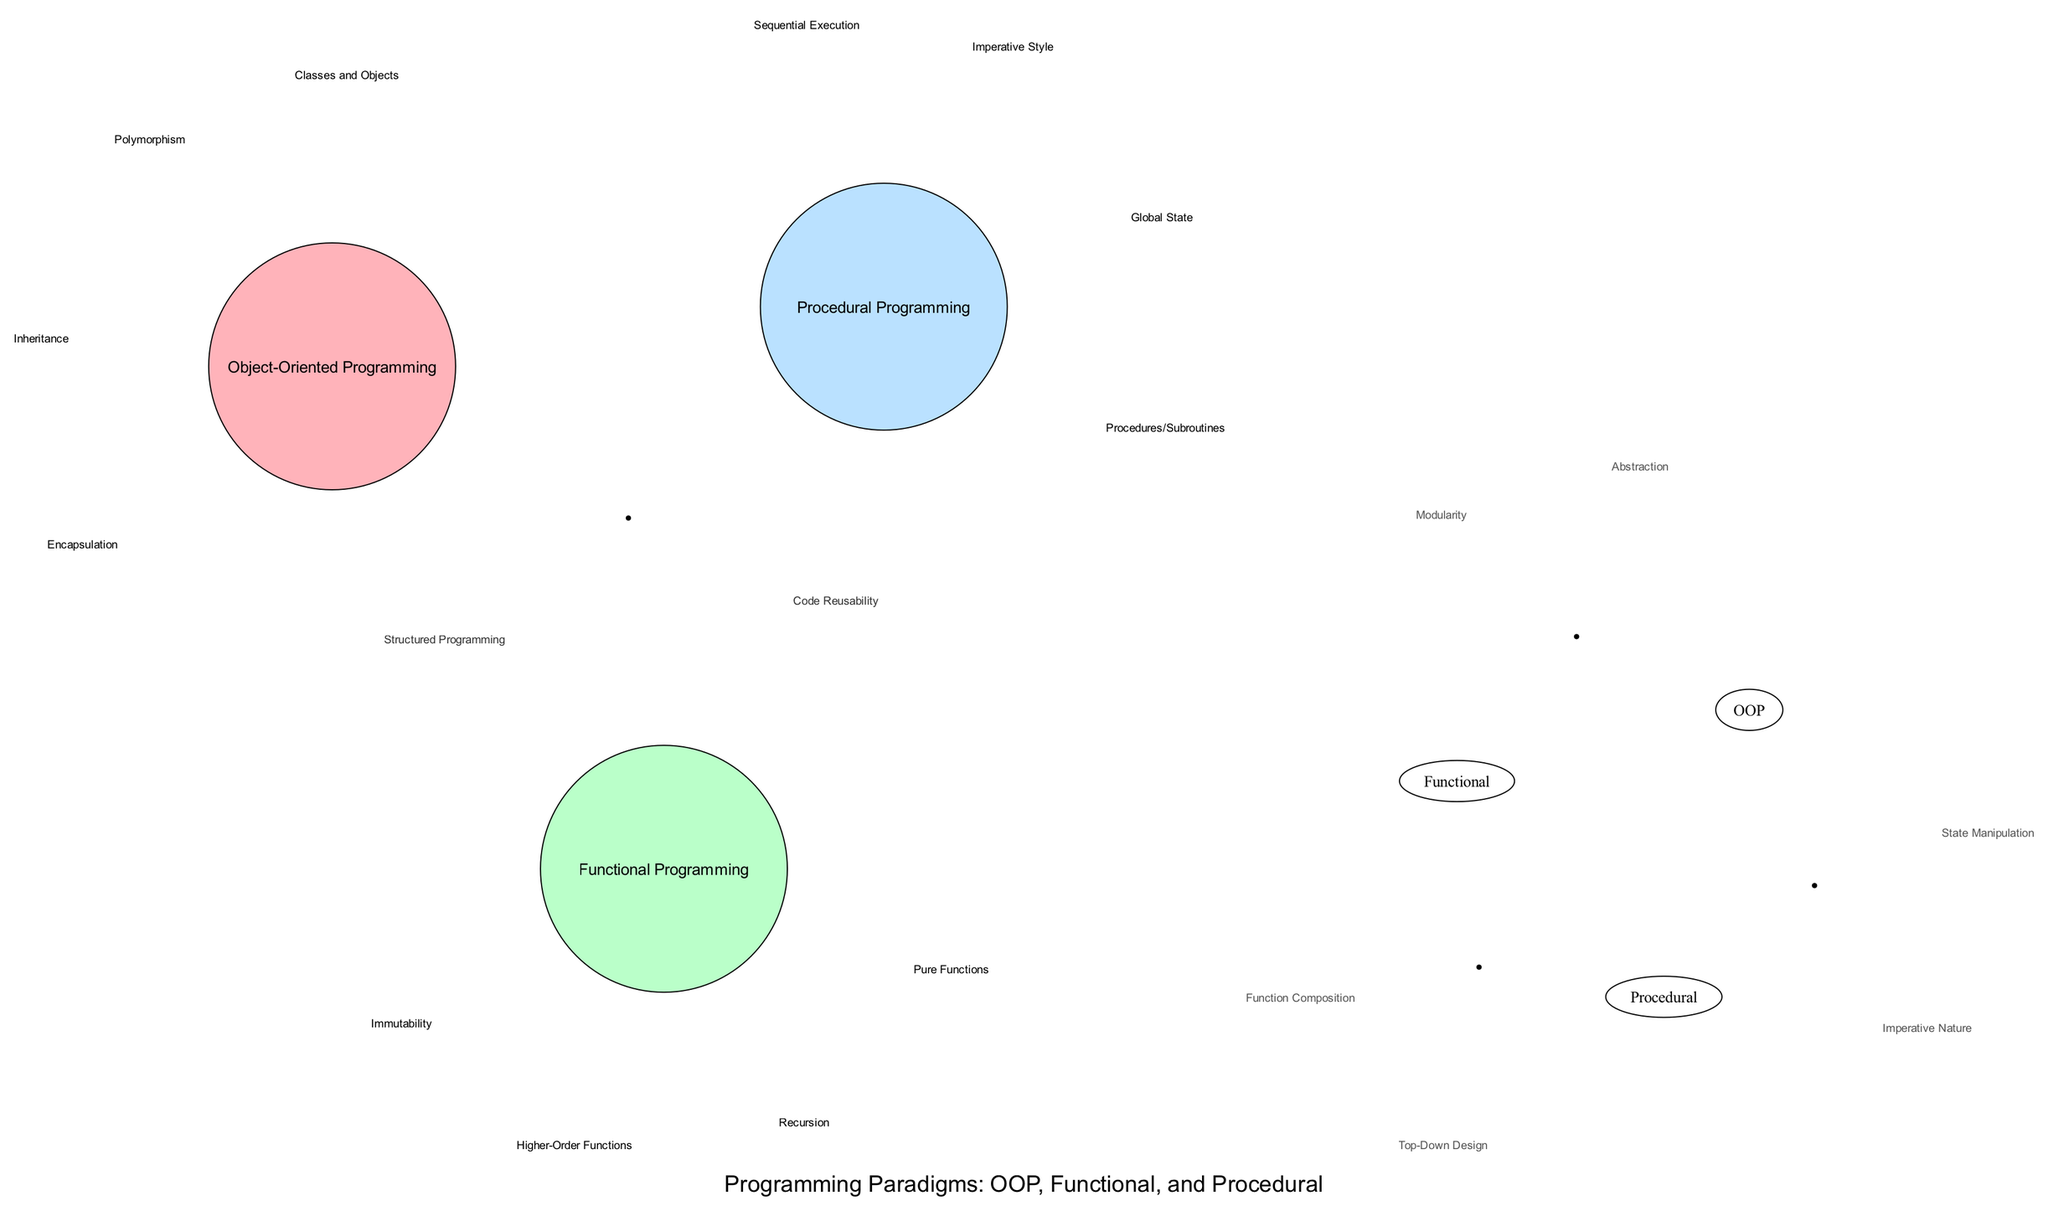What are the features of Object-Oriented Programming? The circle representing Object-Oriented Programming contains four features listed inside it: Classes and Objects, Encapsulation, Inheritance, and Polymorphism.
Answer: Classes and Objects, Encapsulation, Inheritance, Polymorphism How many features are unique to Functional Programming? The circle for Functional Programming has four features within it: Immutability, Pure Functions, Higher-Order Functions, and Recursion. Since none of these features are found in the other circles, they are all unique.
Answer: Four What features are shared by all three programming paradigms? The center intersection of the diagram represents features that are common to all three programming paradigms. It includes Code Reusability and Structured Programming as its features, which are shared across the paradigms.
Answer: Code Reusability, Structured Programming Which programming paradigms share the feature of State Manipulation? The feature State Manipulation appears in the intersection between Object-Oriented Programming and Procedural Programming, indicating that these two paradigms share this feature specifically.
Answer: Object-Oriented Programming, Procedural Programming How many total unique features are mentioned across all programming paradigms? To find the total unique features, we count the individual features listed in each programming paradigm, as well as those shared in the intersections. Unique feature counts yield: 4 (OOP) + 4 (Functional) + 4 (Procedural) + 2 (OOP and Functional) + 2 (OOP and Procedural) + 2 (Functional and Procedural) + 2 (All) = 20 features in total.
Answer: Twenty What feature serves as a basis for both Object-Oriented and Functional Programming? The features listed in the intersection between Object-Oriented Programming and Functional Programming include Modularity and Abstraction, indicating that both paradigms have these attributes in common.
Answer: Modularity, Abstraction How does the Imperative Style feature relate to Procedural and Object-Oriented Programming? The Imperative Style is mentioned as a feature in the intersection between Procedural Programming and Object-Oriented Programming, showing it is a characteristic common to both paradigms, linking their approach to programming.
Answer: Procedural Programming, Object-Oriented Programming What is the primary programming style reflected in the features of Procedural Programming? The features include Sequential Execution, Procedures/Subroutines, Global State, and Imperative Style, which collectively represent an imperative method of programming typical of the Procedural paradigm.
Answer: Imperative Style Which programming paradigm places a strong emphasis on Immutability? The circle for Functional Programming lists Immutability as one of its defining features, demonstrating its strong emphasis on avoiding state changes.
Answer: Functional Programming 